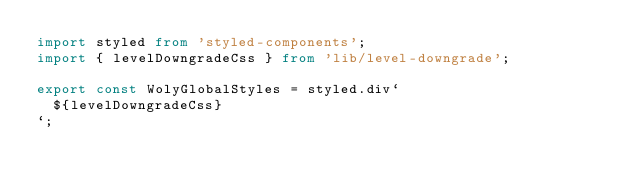<code> <loc_0><loc_0><loc_500><loc_500><_TypeScript_>import styled from 'styled-components';
import { levelDowngradeCss } from 'lib/level-downgrade';

export const WolyGlobalStyles = styled.div`
  ${levelDowngradeCss}
`;
</code> 